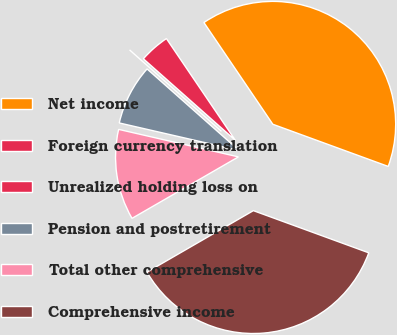Convert chart. <chart><loc_0><loc_0><loc_500><loc_500><pie_chart><fcel>Net income<fcel>Foreign currency translation<fcel>Unrealized holding loss on<fcel>Pension and postretirement<fcel>Total other comprehensive<fcel>Comprehensive income<nl><fcel>40.05%<fcel>3.98%<fcel>0.0%<fcel>7.95%<fcel>11.93%<fcel>36.08%<nl></chart> 